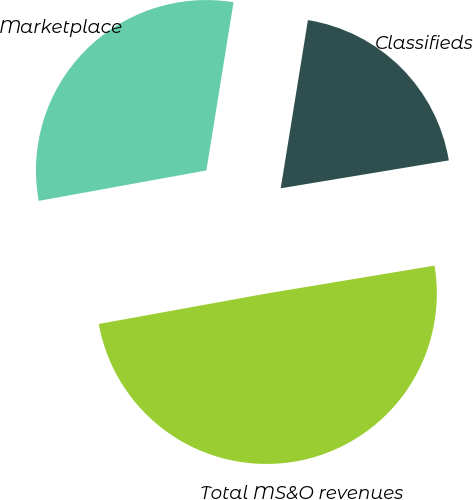Convert chart to OTSL. <chart><loc_0><loc_0><loc_500><loc_500><pie_chart><fcel>Marketplace<fcel>Classifieds<fcel>Total MS&O revenues<nl><fcel>30.41%<fcel>19.83%<fcel>49.76%<nl></chart> 